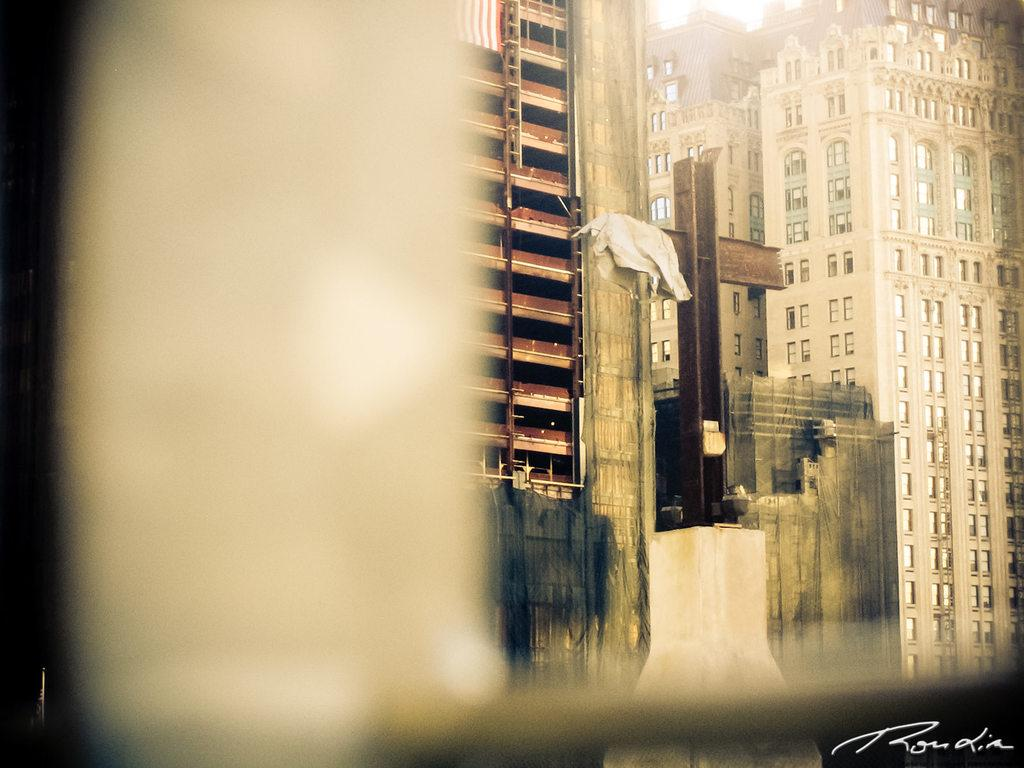What type of structures can be seen in the image? There are buildings in the image. Can you describe any other objects or features in the image? There is a cloth on a pole in the image. What type of furniture is visible in the image? There is no furniture present in the image. Who is the partner of the person in the image? There is no person present in the image, so it is not possible to determine who their partner might be. 